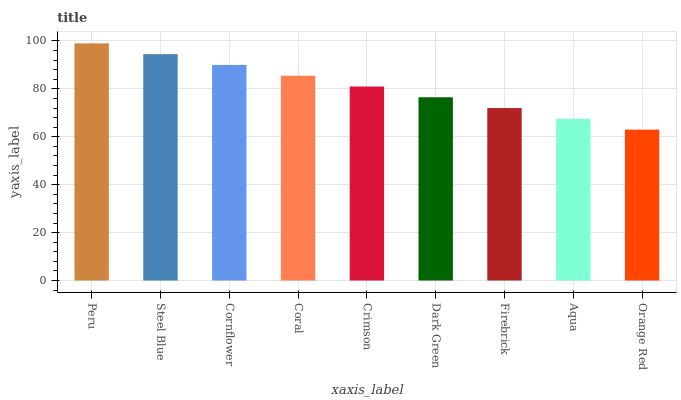Is Orange Red the minimum?
Answer yes or no. Yes. Is Peru the maximum?
Answer yes or no. Yes. Is Steel Blue the minimum?
Answer yes or no. No. Is Steel Blue the maximum?
Answer yes or no. No. Is Peru greater than Steel Blue?
Answer yes or no. Yes. Is Steel Blue less than Peru?
Answer yes or no. Yes. Is Steel Blue greater than Peru?
Answer yes or no. No. Is Peru less than Steel Blue?
Answer yes or no. No. Is Crimson the high median?
Answer yes or no. Yes. Is Crimson the low median?
Answer yes or no. Yes. Is Firebrick the high median?
Answer yes or no. No. Is Firebrick the low median?
Answer yes or no. No. 